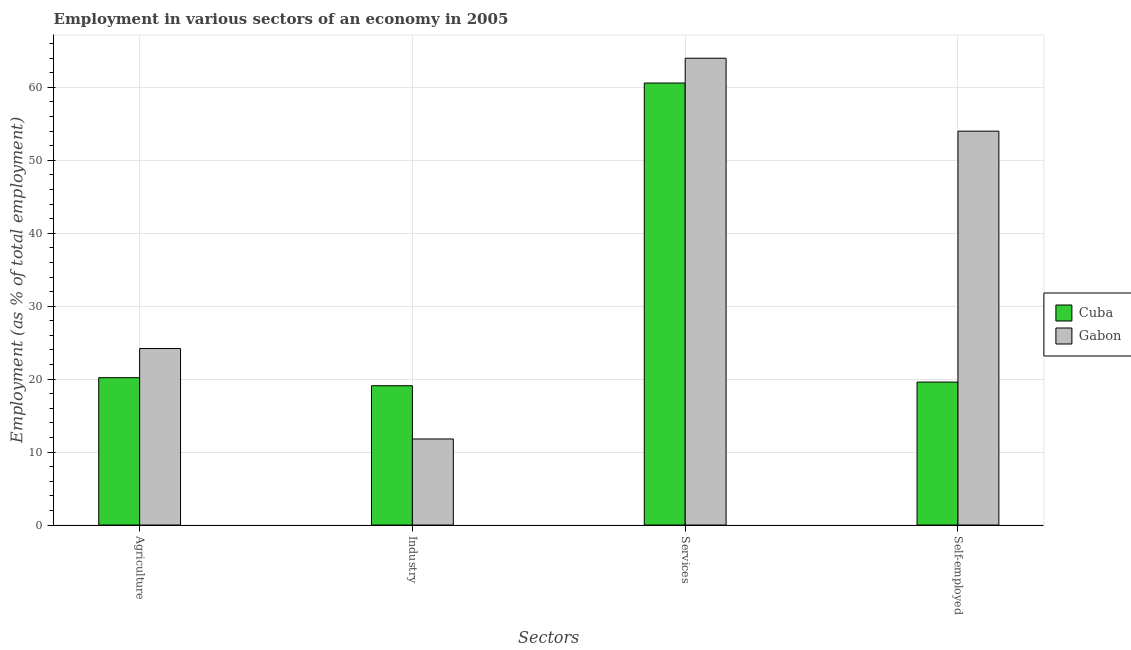How many different coloured bars are there?
Ensure brevity in your answer.  2. Are the number of bars per tick equal to the number of legend labels?
Ensure brevity in your answer.  Yes. What is the label of the 3rd group of bars from the left?
Offer a terse response. Services. What is the percentage of workers in services in Cuba?
Provide a succinct answer. 60.6. Across all countries, what is the minimum percentage of self employed workers?
Give a very brief answer. 19.6. In which country was the percentage of workers in services maximum?
Make the answer very short. Gabon. In which country was the percentage of self employed workers minimum?
Give a very brief answer. Cuba. What is the total percentage of workers in agriculture in the graph?
Your answer should be compact. 44.4. What is the difference between the percentage of workers in industry in Gabon and that in Cuba?
Offer a terse response. -7.3. What is the difference between the percentage of workers in agriculture in Cuba and the percentage of self employed workers in Gabon?
Offer a very short reply. -33.8. What is the average percentage of workers in services per country?
Provide a short and direct response. 62.3. What is the difference between the percentage of workers in agriculture and percentage of self employed workers in Cuba?
Your response must be concise. 0.6. What is the ratio of the percentage of workers in services in Gabon to that in Cuba?
Give a very brief answer. 1.06. Is the percentage of workers in services in Cuba less than that in Gabon?
Offer a very short reply. Yes. Is the difference between the percentage of workers in agriculture in Cuba and Gabon greater than the difference between the percentage of self employed workers in Cuba and Gabon?
Your answer should be very brief. Yes. What is the difference between the highest and the second highest percentage of workers in services?
Provide a short and direct response. 3.4. What is the difference between the highest and the lowest percentage of workers in services?
Keep it short and to the point. 3.4. In how many countries, is the percentage of self employed workers greater than the average percentage of self employed workers taken over all countries?
Your answer should be compact. 1. Is the sum of the percentage of self employed workers in Gabon and Cuba greater than the maximum percentage of workers in industry across all countries?
Offer a very short reply. Yes. What does the 2nd bar from the left in Agriculture represents?
Make the answer very short. Gabon. What does the 2nd bar from the right in Agriculture represents?
Your answer should be compact. Cuba. Is it the case that in every country, the sum of the percentage of workers in agriculture and percentage of workers in industry is greater than the percentage of workers in services?
Offer a terse response. No. How many bars are there?
Your response must be concise. 8. What is the difference between two consecutive major ticks on the Y-axis?
Offer a terse response. 10. Does the graph contain any zero values?
Make the answer very short. No. Does the graph contain grids?
Make the answer very short. Yes. Where does the legend appear in the graph?
Give a very brief answer. Center right. How are the legend labels stacked?
Provide a short and direct response. Vertical. What is the title of the graph?
Give a very brief answer. Employment in various sectors of an economy in 2005. Does "Colombia" appear as one of the legend labels in the graph?
Keep it short and to the point. No. What is the label or title of the X-axis?
Keep it short and to the point. Sectors. What is the label or title of the Y-axis?
Make the answer very short. Employment (as % of total employment). What is the Employment (as % of total employment) of Cuba in Agriculture?
Your answer should be very brief. 20.2. What is the Employment (as % of total employment) of Gabon in Agriculture?
Provide a succinct answer. 24.2. What is the Employment (as % of total employment) in Cuba in Industry?
Give a very brief answer. 19.1. What is the Employment (as % of total employment) of Gabon in Industry?
Your answer should be compact. 11.8. What is the Employment (as % of total employment) of Cuba in Services?
Ensure brevity in your answer.  60.6. What is the Employment (as % of total employment) of Cuba in Self-employed?
Provide a succinct answer. 19.6. Across all Sectors, what is the maximum Employment (as % of total employment) in Cuba?
Give a very brief answer. 60.6. Across all Sectors, what is the maximum Employment (as % of total employment) of Gabon?
Provide a short and direct response. 64. Across all Sectors, what is the minimum Employment (as % of total employment) in Cuba?
Your answer should be compact. 19.1. Across all Sectors, what is the minimum Employment (as % of total employment) of Gabon?
Your answer should be compact. 11.8. What is the total Employment (as % of total employment) of Cuba in the graph?
Your response must be concise. 119.5. What is the total Employment (as % of total employment) in Gabon in the graph?
Offer a very short reply. 154. What is the difference between the Employment (as % of total employment) in Gabon in Agriculture and that in Industry?
Give a very brief answer. 12.4. What is the difference between the Employment (as % of total employment) of Cuba in Agriculture and that in Services?
Your answer should be compact. -40.4. What is the difference between the Employment (as % of total employment) in Gabon in Agriculture and that in Services?
Keep it short and to the point. -39.8. What is the difference between the Employment (as % of total employment) of Gabon in Agriculture and that in Self-employed?
Ensure brevity in your answer.  -29.8. What is the difference between the Employment (as % of total employment) in Cuba in Industry and that in Services?
Offer a very short reply. -41.5. What is the difference between the Employment (as % of total employment) of Gabon in Industry and that in Services?
Give a very brief answer. -52.2. What is the difference between the Employment (as % of total employment) of Cuba in Industry and that in Self-employed?
Provide a short and direct response. -0.5. What is the difference between the Employment (as % of total employment) of Gabon in Industry and that in Self-employed?
Provide a short and direct response. -42.2. What is the difference between the Employment (as % of total employment) in Cuba in Services and that in Self-employed?
Provide a short and direct response. 41. What is the difference between the Employment (as % of total employment) of Cuba in Agriculture and the Employment (as % of total employment) of Gabon in Services?
Keep it short and to the point. -43.8. What is the difference between the Employment (as % of total employment) of Cuba in Agriculture and the Employment (as % of total employment) of Gabon in Self-employed?
Ensure brevity in your answer.  -33.8. What is the difference between the Employment (as % of total employment) in Cuba in Industry and the Employment (as % of total employment) in Gabon in Services?
Offer a very short reply. -44.9. What is the difference between the Employment (as % of total employment) in Cuba in Industry and the Employment (as % of total employment) in Gabon in Self-employed?
Provide a succinct answer. -34.9. What is the difference between the Employment (as % of total employment) in Cuba in Services and the Employment (as % of total employment) in Gabon in Self-employed?
Your answer should be compact. 6.6. What is the average Employment (as % of total employment) in Cuba per Sectors?
Make the answer very short. 29.88. What is the average Employment (as % of total employment) in Gabon per Sectors?
Your answer should be very brief. 38.5. What is the difference between the Employment (as % of total employment) in Cuba and Employment (as % of total employment) in Gabon in Agriculture?
Your response must be concise. -4. What is the difference between the Employment (as % of total employment) of Cuba and Employment (as % of total employment) of Gabon in Industry?
Provide a short and direct response. 7.3. What is the difference between the Employment (as % of total employment) of Cuba and Employment (as % of total employment) of Gabon in Services?
Provide a short and direct response. -3.4. What is the difference between the Employment (as % of total employment) in Cuba and Employment (as % of total employment) in Gabon in Self-employed?
Your response must be concise. -34.4. What is the ratio of the Employment (as % of total employment) in Cuba in Agriculture to that in Industry?
Offer a very short reply. 1.06. What is the ratio of the Employment (as % of total employment) in Gabon in Agriculture to that in Industry?
Provide a short and direct response. 2.05. What is the ratio of the Employment (as % of total employment) of Cuba in Agriculture to that in Services?
Make the answer very short. 0.33. What is the ratio of the Employment (as % of total employment) in Gabon in Agriculture to that in Services?
Make the answer very short. 0.38. What is the ratio of the Employment (as % of total employment) of Cuba in Agriculture to that in Self-employed?
Your answer should be very brief. 1.03. What is the ratio of the Employment (as % of total employment) in Gabon in Agriculture to that in Self-employed?
Your response must be concise. 0.45. What is the ratio of the Employment (as % of total employment) of Cuba in Industry to that in Services?
Offer a terse response. 0.32. What is the ratio of the Employment (as % of total employment) in Gabon in Industry to that in Services?
Provide a succinct answer. 0.18. What is the ratio of the Employment (as % of total employment) of Cuba in Industry to that in Self-employed?
Your answer should be compact. 0.97. What is the ratio of the Employment (as % of total employment) of Gabon in Industry to that in Self-employed?
Ensure brevity in your answer.  0.22. What is the ratio of the Employment (as % of total employment) of Cuba in Services to that in Self-employed?
Ensure brevity in your answer.  3.09. What is the ratio of the Employment (as % of total employment) of Gabon in Services to that in Self-employed?
Keep it short and to the point. 1.19. What is the difference between the highest and the second highest Employment (as % of total employment) in Cuba?
Your response must be concise. 40.4. What is the difference between the highest and the lowest Employment (as % of total employment) in Cuba?
Your response must be concise. 41.5. What is the difference between the highest and the lowest Employment (as % of total employment) in Gabon?
Give a very brief answer. 52.2. 